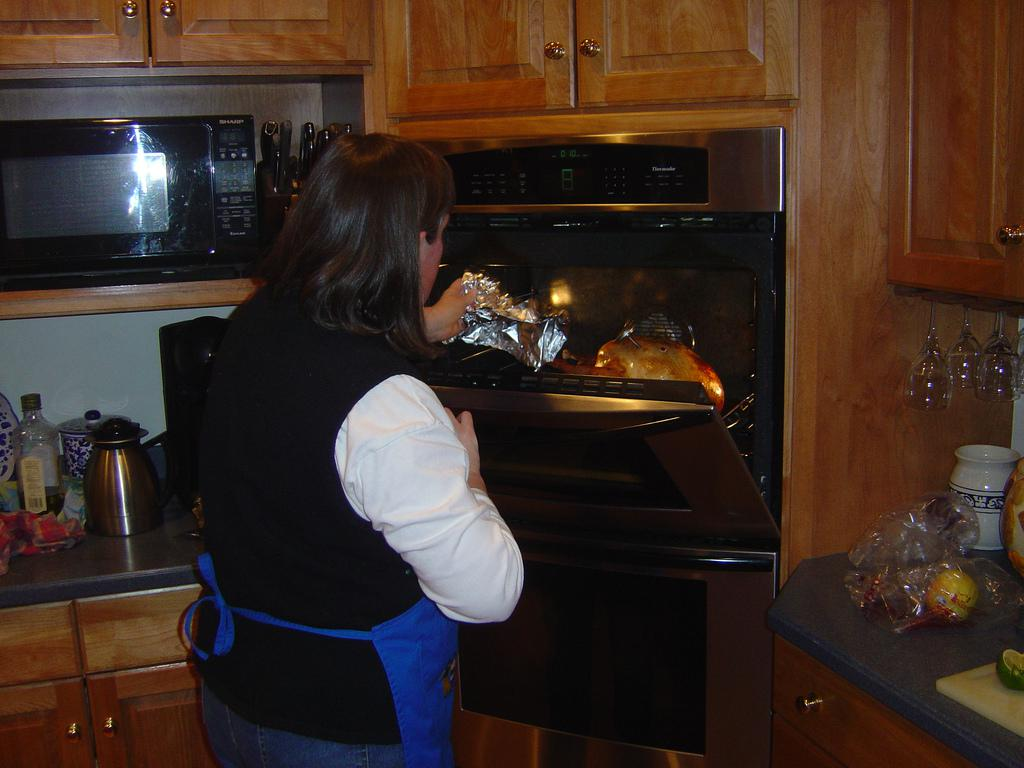Question: what is this woman doing?
Choices:
A. Washing clothes.
B. Cleaning.
C. Cooking.
D. Doing her hair.
Answer with the letter. Answer: C Question: why is the oven open?
Choices:
A. Cleaning it.
B. Checking the temperature.
C. Checking the food.
D. Getting out the food.
Answer with the letter. Answer: C Question: what color hair does the woman have?
Choices:
A. Brian.
B. Orange.
C. Blue.
D. Green.
Answer with the letter. Answer: A Question: what kind of cabinets are in the kitchen?
Choices:
A. Steel.
B. Metal.
C. Wooden.
D. Aluminum.
Answer with the letter. Answer: C Question: what color are the counters?
Choices:
A. Dark grey.
B. Blue.
C. Red.
D. Black.
Answer with the letter. Answer: A Question: what is the woman holding?
Choices:
A. Saran wrap.
B. Tongs.
C. A knife.
D. Aluminum foil.
Answer with the letter. Answer: D Question: where was this picture taken?
Choices:
A. At a restaurant.
B. At a culinary school.
C. In a kitchen.
D. At a model home.
Answer with the letter. Answer: C Question: what is above the counter?
Choices:
A. Cupboards.
B. A second oven.
C. A light.
D. A microwave oven.
Answer with the letter. Answer: D Question: how is the lime cut?
Choices:
A. In quarters.
B. In wedges.
C. In half.
D. In slices.
Answer with the letter. Answer: C Question: where are wine glasses hanging?
Choices:
A. Under the wine bottles.
B. Under the cabinets.
C. Over the sink.
D. Over the stove.
Answer with the letter. Answer: B Question: what did the lady do to the foil?
Choices:
A. Recycled the foil.
B. Put the foil in the trash.
C. Crinkled the aluminum foil.
D. Reused the foil.
Answer with the letter. Answer: C Question: what color is the fowl's skin?
Choices:
A. White.
B. It is brown.
C. Black.
D. Yellow.
Answer with the letter. Answer: B 